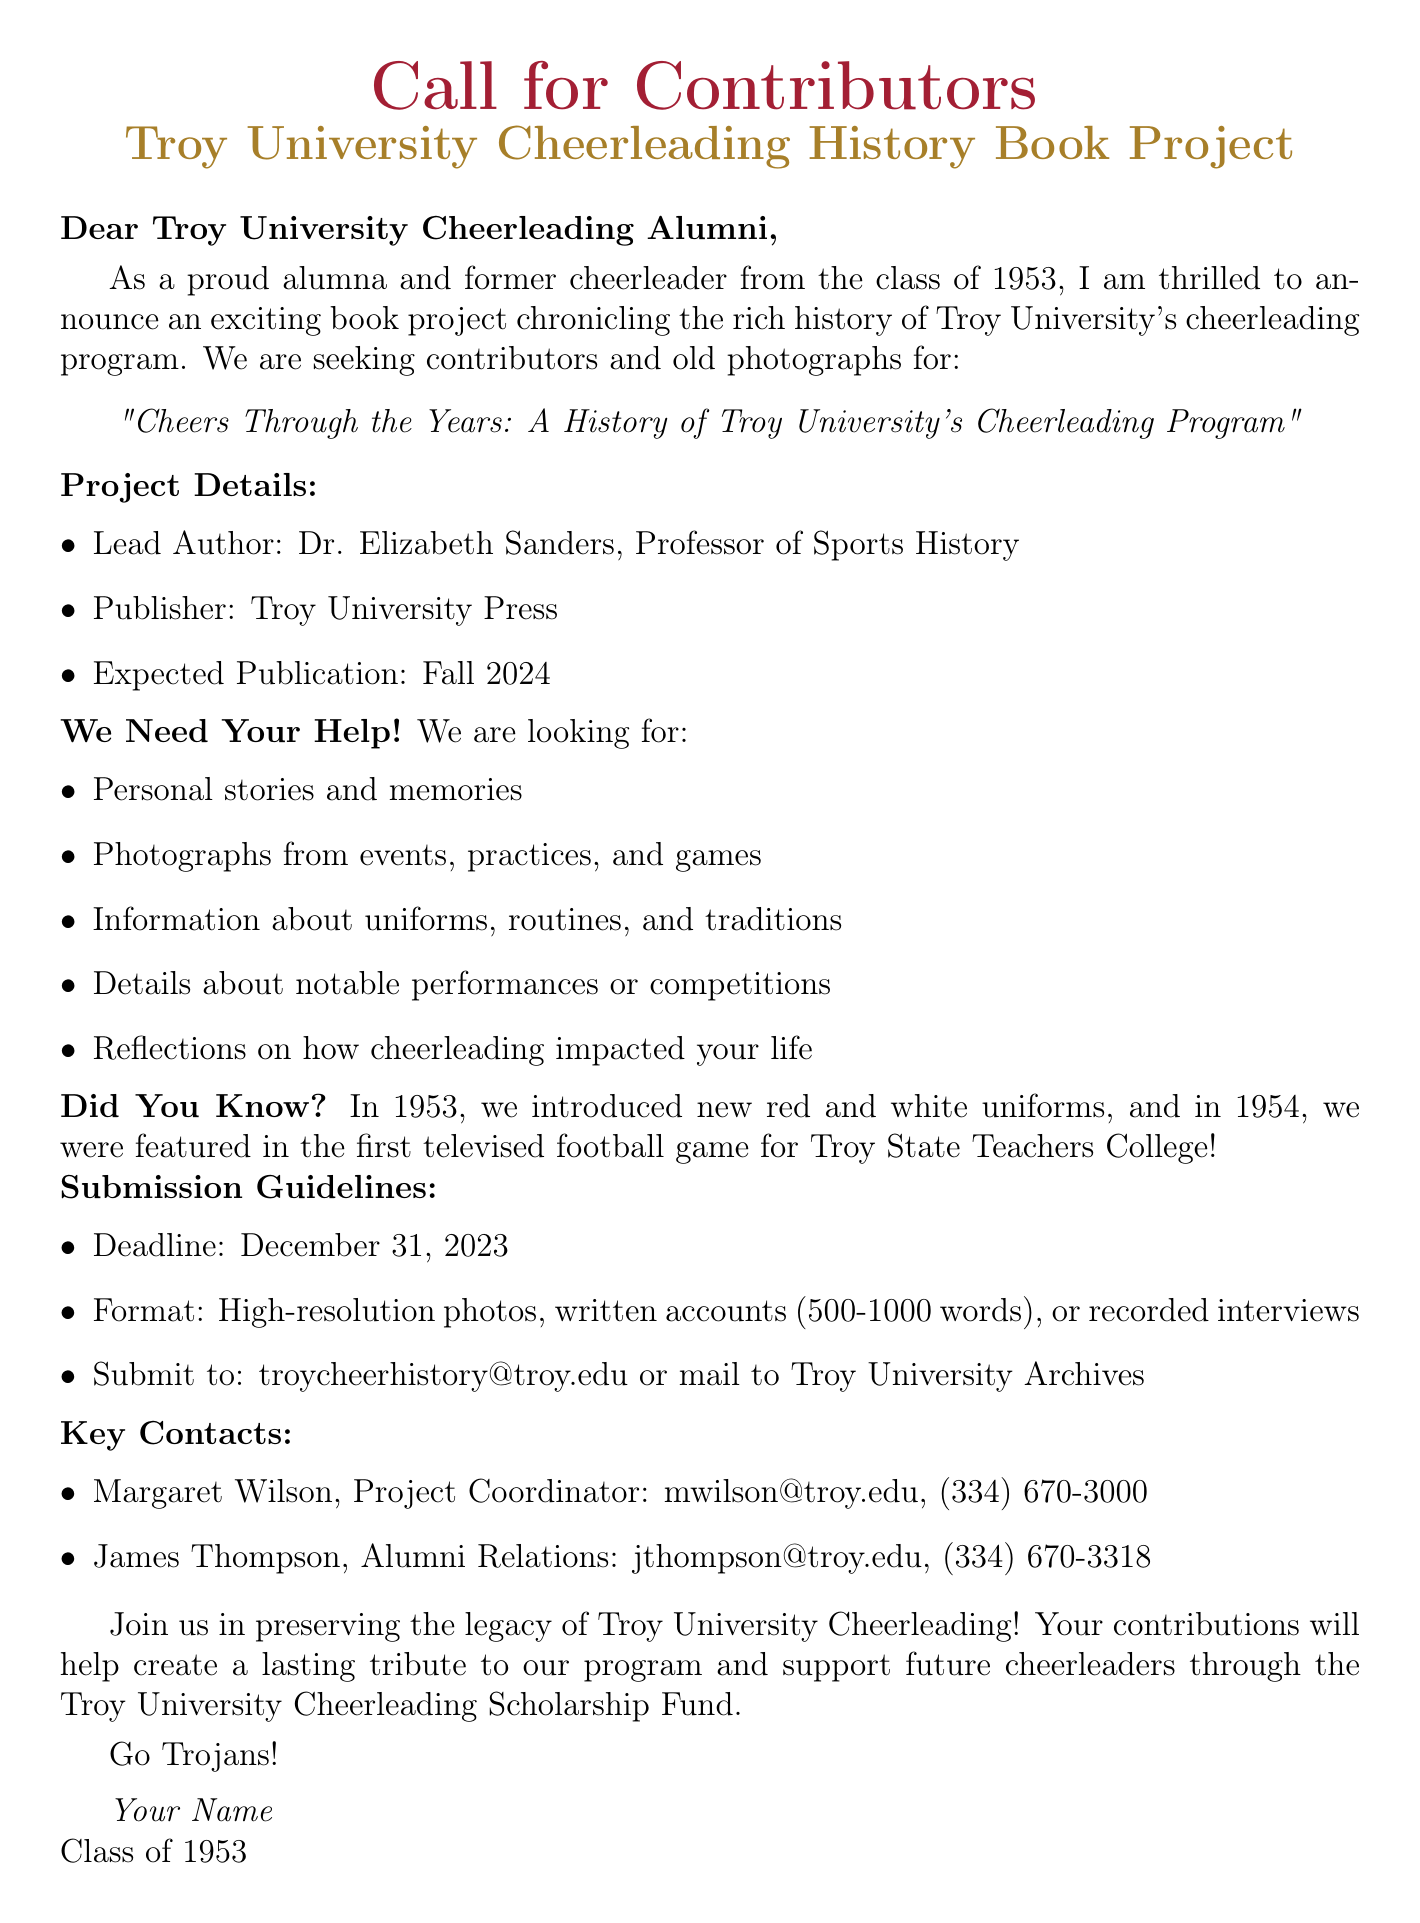What is the title of the book project? The title of the book project is specified in the document and is related to the history of the cheerleading program.
Answer: Cheers Through the Years: A History of Troy University's Cheerleading Program Who is the lead author of the book? The document clearly indicates who the lead author is, highlighting their position within the university.
Answer: Dr. Elizabeth Sanders What is the expected publication date of the book? The expected publication date is mentioned in the project overview section of the document.
Answer: Fall 2024 What is the submission deadline for contributions? The document specifies a deadline for when contributions need to be submitted.
Answer: December 31, 2023 What type of contributions is the project seeking? The document lists specific types of contributions that are requested from former cheerleaders.
Answer: Personal stories and memories In what year were new red and white uniforms introduced for the cheerleading squad? The document provides a specific event from the timeline related to cheerleading uniforms.
Answer: 1953 What format should photographs be in for submission? The submission guidelines specify the required format for photographs that contributors should follow.
Answer: High-resolution digital scans or original photographs Who should be contacted for more information about the project? The document includes key contacts along with their roles and contact details for inquiries.
Answer: Margaret Wilson 